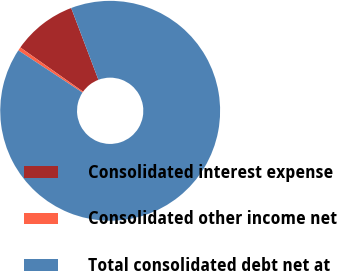Convert chart to OTSL. <chart><loc_0><loc_0><loc_500><loc_500><pie_chart><fcel>Consolidated interest expense<fcel>Consolidated other income net<fcel>Total consolidated debt net at<nl><fcel>9.46%<fcel>0.51%<fcel>90.04%<nl></chart> 